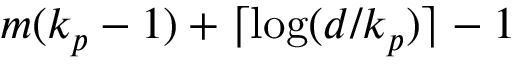<formula> <loc_0><loc_0><loc_500><loc_500>m ( k _ { p } - 1 ) + \lceil \log ( d / k _ { p } ) \rceil - 1</formula> 